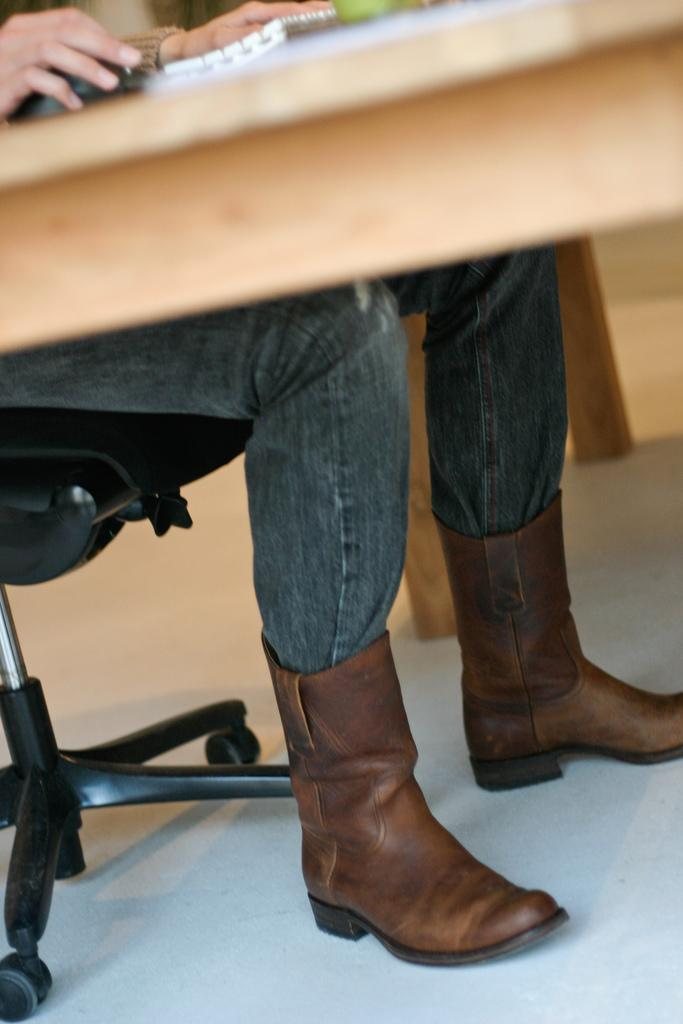What is the person in the image doing? The person is sitting on a chair in the image. What material is the table made of in the image? The table in the image is made of wood. What type of copper object can be seen in the image? There is no copper object present in the image. Is the person's brother sitting next to them in the image? The provided facts do not mention any siblings or other people in the image, so it cannot be determined if the person's brother is present. 